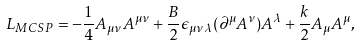<formula> <loc_0><loc_0><loc_500><loc_500>L _ { M C S P } = - \frac { 1 } { 4 } A _ { \mu \nu } A ^ { \mu \nu } + \frac { B } { 2 } \epsilon _ { \mu \nu \lambda } ( \partial ^ { \mu } A ^ { \nu } ) A ^ { \lambda } + \frac { k } { 2 } A _ { \mu } A ^ { \mu } ,</formula> 